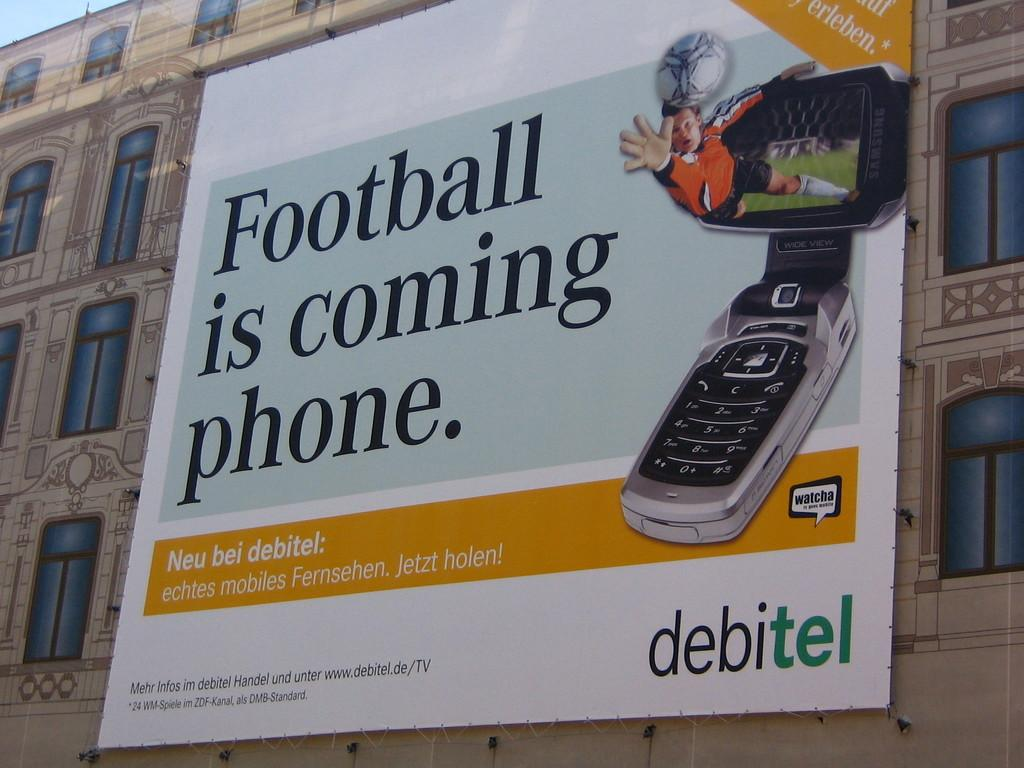What is the main subject of the image? The main subject of the image is a picture of a building. Are there any additional features on the building? Yes, there is an advertisement on the building. What type of loaf is being advertised on the building in the image? There is no loaf being advertised on the building in the image; it features an advertisement, but the content of the advertisement is not specified. 